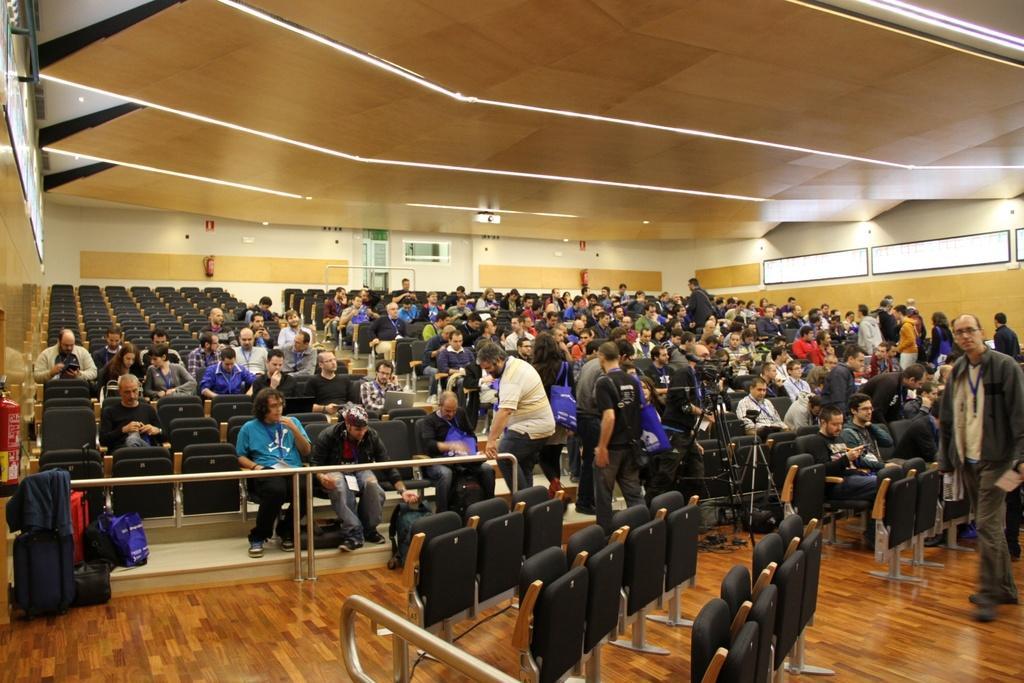How would you summarize this image in a sentence or two? This image consists of many people sitting. It looks like a conference hall. There are many chairs in this image. At the top, there is a roof. At the bottom, there is a floor. 